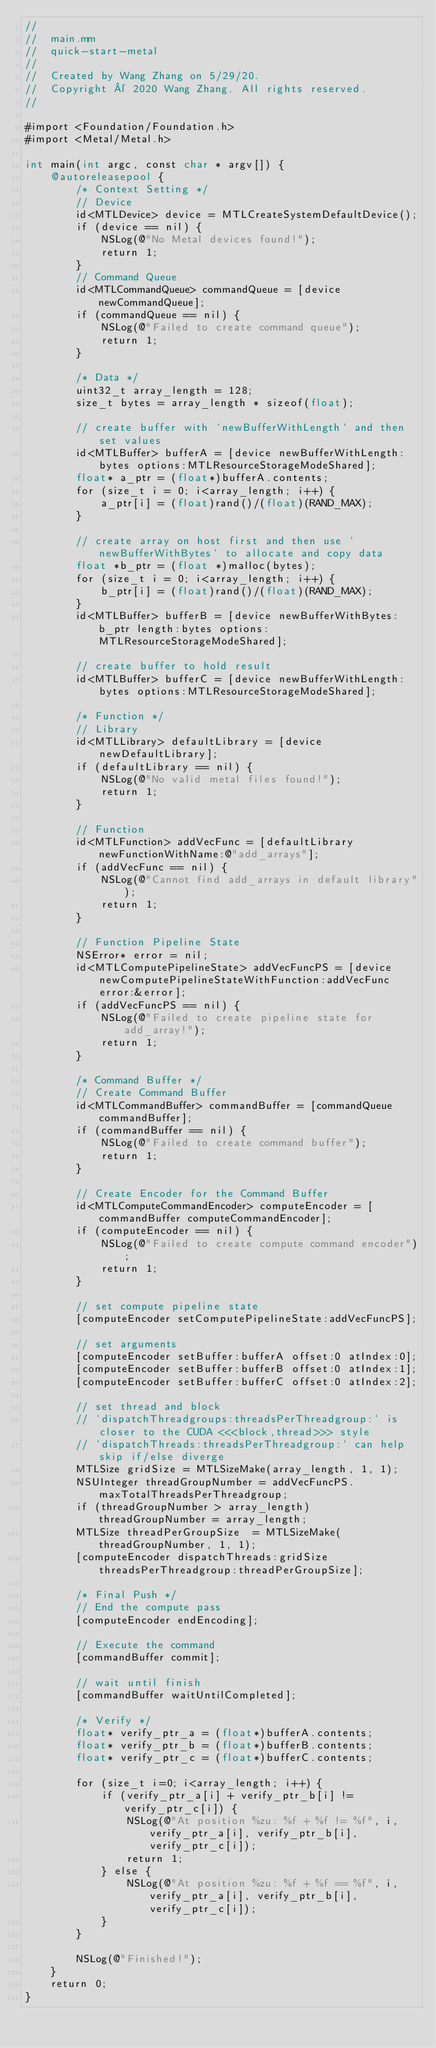<code> <loc_0><loc_0><loc_500><loc_500><_ObjectiveC_>//
//  main.mm
//  quick-start-metal
//
//  Created by Wang Zhang on 5/29/20.
//  Copyright © 2020 Wang Zhang. All rights reserved.
//

#import <Foundation/Foundation.h>
#import <Metal/Metal.h>

int main(int argc, const char * argv[]) {
    @autoreleasepool {
        /* Context Setting */
        // Device
        id<MTLDevice> device = MTLCreateSystemDefaultDevice();
        if (device == nil) {
            NSLog(@"No Metal devices found!");
            return 1;
        }
        // Command Queue
        id<MTLCommandQueue> commandQueue = [device newCommandQueue];
        if (commandQueue == nil) {
            NSLog(@"Failed to create command queue");
            return 1;
        }
                
        /* Data */
        uint32_t array_length = 128;
        size_t bytes = array_length * sizeof(float);
        
        // create buffer with `newBufferWithLength` and then set values
        id<MTLBuffer> bufferA = [device newBufferWithLength:bytes options:MTLResourceStorageModeShared];
        float* a_ptr = (float*)bufferA.contents;
        for (size_t i = 0; i<array_length; i++) {
            a_ptr[i] = (float)rand()/(float)(RAND_MAX);
        }
        
        // create array on host first and then use `newBufferWithBytes` to allocate and copy data
        float *b_ptr = (float *)malloc(bytes);
        for (size_t i = 0; i<array_length; i++) {
            b_ptr[i] = (float)rand()/(float)(RAND_MAX);
        }
        id<MTLBuffer> bufferB = [device newBufferWithBytes:b_ptr length:bytes options:MTLResourceStorageModeShared];
        
        // create buffer to hold result
        id<MTLBuffer> bufferC = [device newBufferWithLength:bytes options:MTLResourceStorageModeShared];
        
        /* Function */
        // Library
        id<MTLLibrary> defaultLibrary = [device newDefaultLibrary];
        if (defaultLibrary == nil) {
            NSLog(@"No valid metal files found!");
            return 1;
        }
        
        // Function
        id<MTLFunction> addVecFunc = [defaultLibrary newFunctionWithName:@"add_arrays"];
        if (addVecFunc == nil) {
            NSLog(@"Cannot find add_arrays in default library");
            return 1;
        }
        
        // Function Pipeline State
        NSError* error = nil;
        id<MTLComputePipelineState> addVecFuncPS = [device newComputePipelineStateWithFunction:addVecFunc error:&error];
        if (addVecFuncPS == nil) {
            NSLog(@"Failed to create pipeline state for add_array!");
            return 1;
        }
        
        /* Command Buffer */
        // Create Command Buffer
        id<MTLCommandBuffer> commandBuffer = [commandQueue commandBuffer];
        if (commandBuffer == nil) {
            NSLog(@"Failed to create command buffer");
            return 1;
        }
        
        // Create Encoder for the Command Buffer
        id<MTLComputeCommandEncoder> computeEncoder = [commandBuffer computeCommandEncoder];
        if (computeEncoder == nil) {
            NSLog(@"Failed to create compute command encoder");
            return 1;
        }
        
        // set compute pipeline state
        [computeEncoder setComputePipelineState:addVecFuncPS];
        
        // set arguments
        [computeEncoder setBuffer:bufferA offset:0 atIndex:0];
        [computeEncoder setBuffer:bufferB offset:0 atIndex:1];
        [computeEncoder setBuffer:bufferC offset:0 atIndex:2];
        
        // set thread and block
        // `dispatchThreadgroups:threadsPerThreadgroup:` is closer to the CUDA <<<block,thread>>> style
        // `dispatchThreads:threadsPerThreadgroup:` can help skip if/else diverge
        MTLSize gridSize = MTLSizeMake(array_length, 1, 1);
        NSUInteger threadGroupNumber = addVecFuncPS.maxTotalThreadsPerThreadgroup;
        if (threadGroupNumber > array_length) threadGroupNumber = array_length;
        MTLSize threadPerGroupSize  = MTLSizeMake(threadGroupNumber, 1, 1);
        [computeEncoder dispatchThreads:gridSize threadsPerThreadgroup:threadPerGroupSize];
        
        /* Final Push */
        // End the compute pass
        [computeEncoder endEncoding];
        
        // Execute the command
        [commandBuffer commit];
        
        // wait until finish
        [commandBuffer waitUntilCompleted];
        
        /* Verify */
        float* verify_ptr_a = (float*)bufferA.contents;
        float* verify_ptr_b = (float*)bufferB.contents;
        float* verify_ptr_c = (float*)bufferC.contents;
        
        for (size_t i=0; i<array_length; i++) {
            if (verify_ptr_a[i] + verify_ptr_b[i] != verify_ptr_c[i]) {
                NSLog(@"At position %zu: %f + %f != %f", i, verify_ptr_a[i], verify_ptr_b[i], verify_ptr_c[i]);
                return 1;
            } else {
                NSLog(@"At position %zu: %f + %f == %f", i, verify_ptr_a[i], verify_ptr_b[i], verify_ptr_c[i]);
            }
        }
        
        NSLog(@"Finished!");
    }
    return 0;
}
</code> 